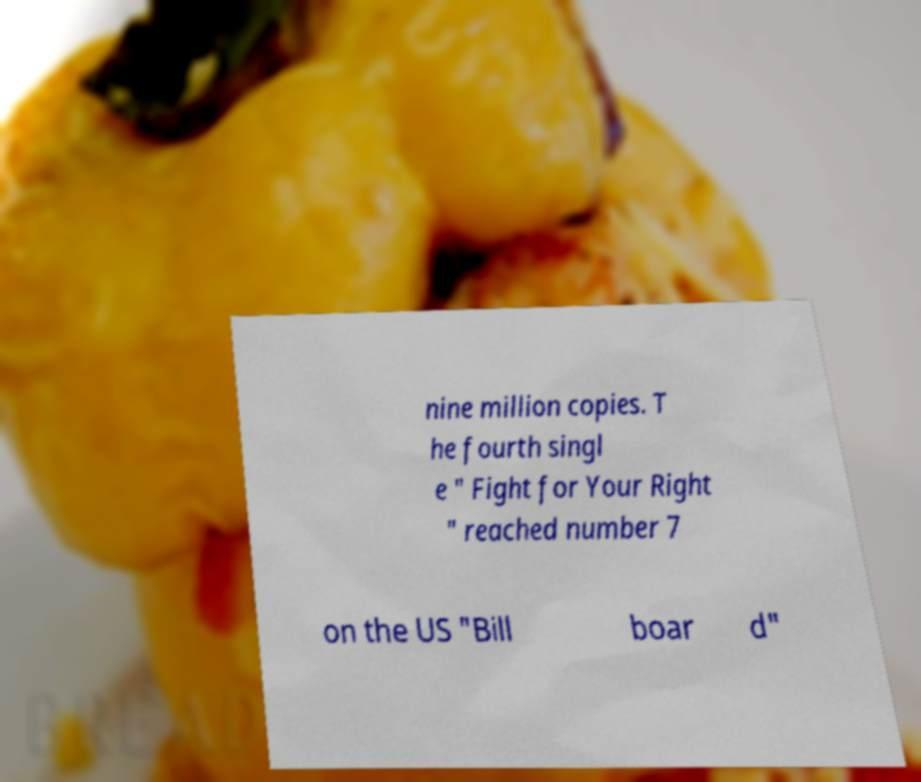Please read and relay the text visible in this image. What does it say? nine million copies. T he fourth singl e " Fight for Your Right " reached number 7 on the US "Bill boar d" 